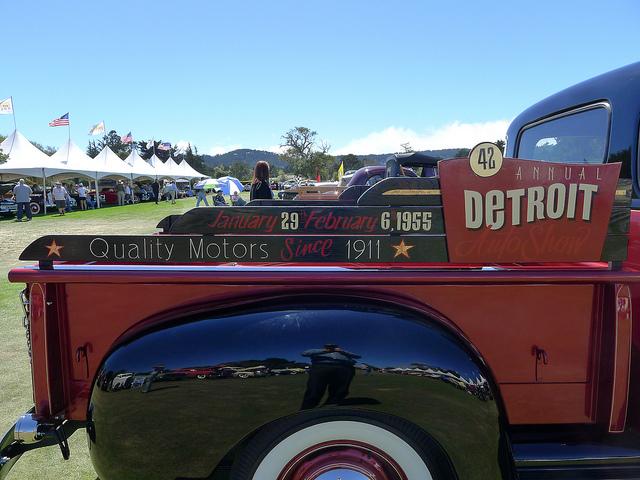Is the car dirty?
Be succinct. No. What year did Quality Motors start?
Concise answer only. 1911. Is this pickup truck being judged at an antique car show?
Give a very brief answer. Yes. 